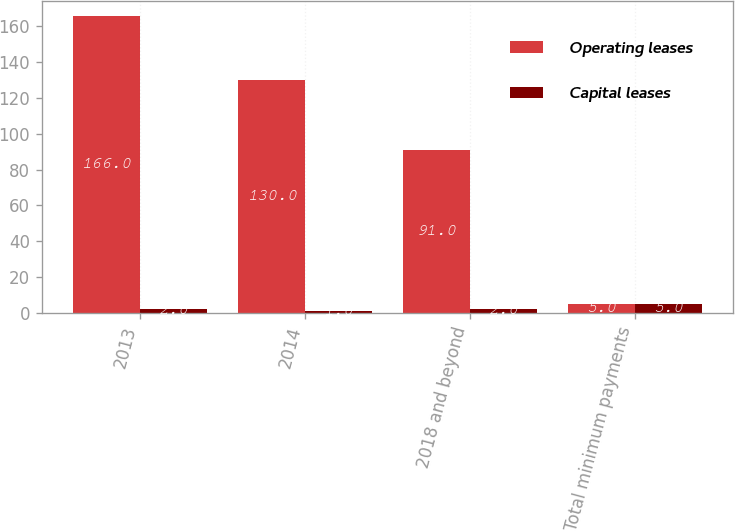<chart> <loc_0><loc_0><loc_500><loc_500><stacked_bar_chart><ecel><fcel>2013<fcel>2014<fcel>2018 and beyond<fcel>Total minimum payments<nl><fcel>Operating leases<fcel>166<fcel>130<fcel>91<fcel>5<nl><fcel>Capital leases<fcel>2<fcel>1<fcel>2<fcel>5<nl></chart> 